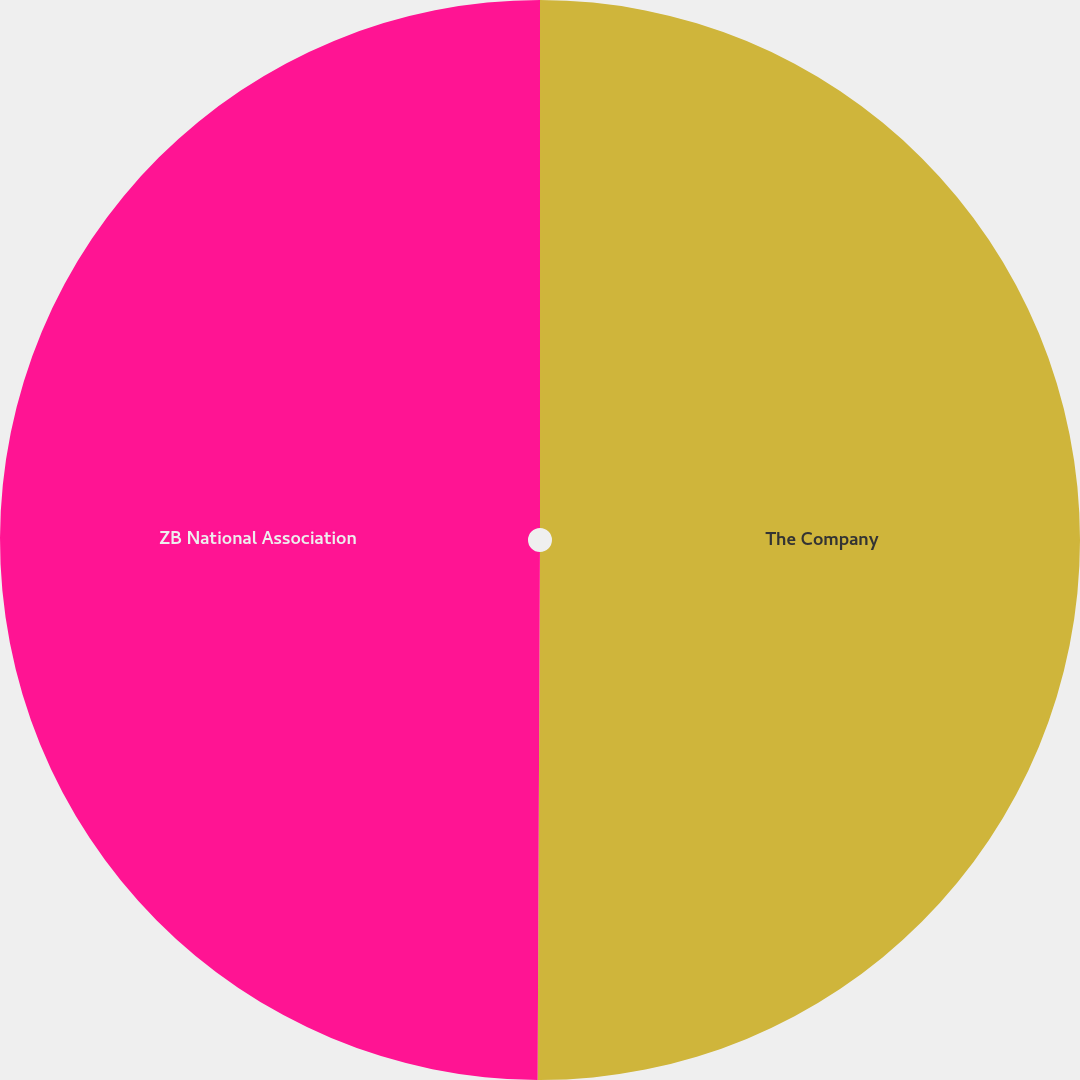Convert chart to OTSL. <chart><loc_0><loc_0><loc_500><loc_500><pie_chart><fcel>The Company<fcel>ZB National Association<nl><fcel>50.07%<fcel>49.93%<nl></chart> 